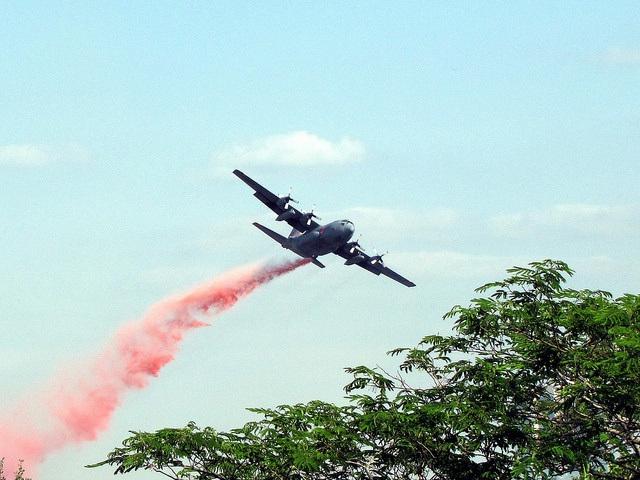Describe the objects in this image and their specific colors. I can see a airplane in lightblue, black, and gray tones in this image. 